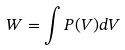Convert formula to latex. <formula><loc_0><loc_0><loc_500><loc_500>W = \int P ( V ) d V</formula> 